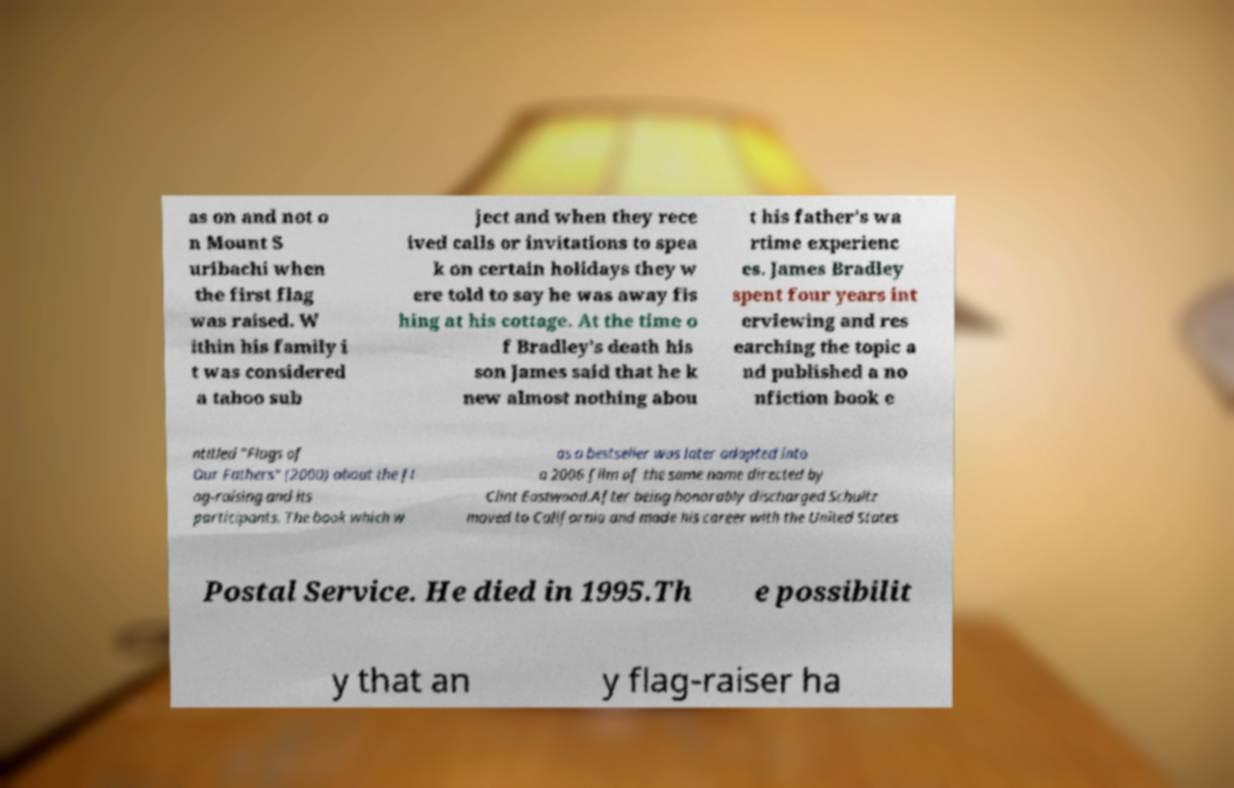Can you read and provide the text displayed in the image?This photo seems to have some interesting text. Can you extract and type it out for me? as on and not o n Mount S uribachi when the first flag was raised. W ithin his family i t was considered a taboo sub ject and when they rece ived calls or invitations to spea k on certain holidays they w ere told to say he was away fis hing at his cottage. At the time o f Bradley's death his son James said that he k new almost nothing abou t his father's wa rtime experienc es. James Bradley spent four years int erviewing and res earching the topic a nd published a no nfiction book e ntitled "Flags of Our Fathers" (2000) about the fl ag-raising and its participants. The book which w as a bestseller was later adapted into a 2006 film of the same name directed by Clint Eastwood.After being honorably discharged Schultz moved to California and made his career with the United States Postal Service. He died in 1995.Th e possibilit y that an y flag-raiser ha 